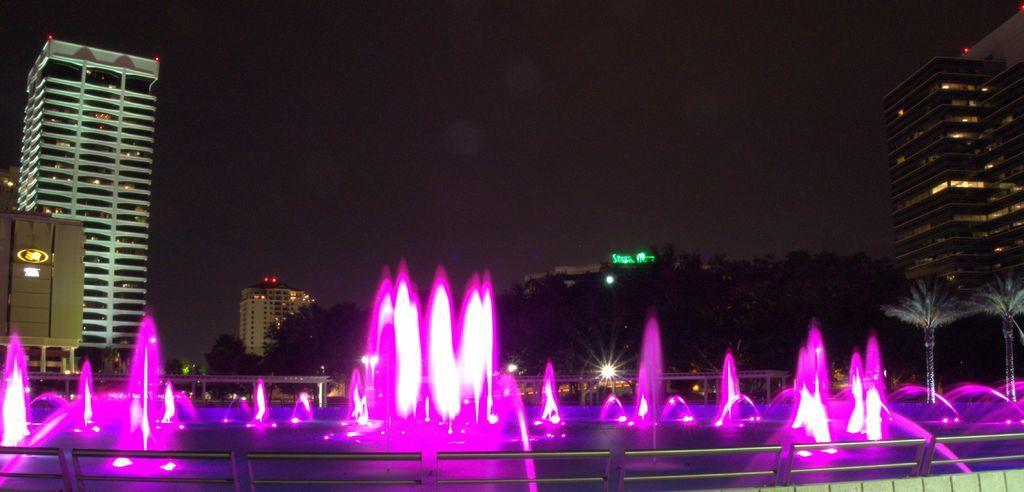Describe this image in one or two sentences. In the picture we can see a fountain with pink color and around it we can see railing and behind it, we can see some buildings, tower buildings and trees and behind it we can see a sky. 